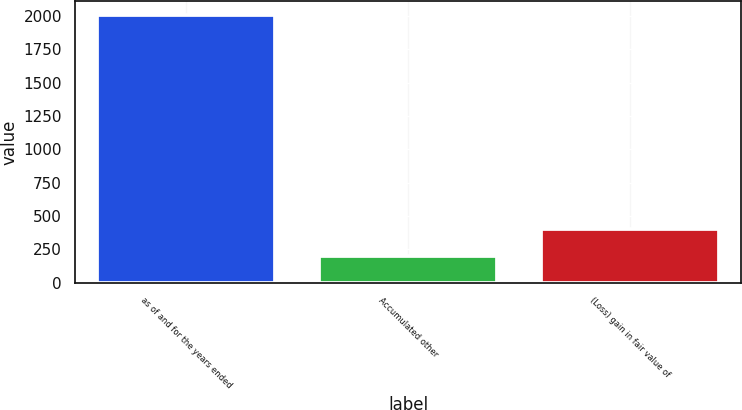<chart> <loc_0><loc_0><loc_500><loc_500><bar_chart><fcel>as of and for the years ended<fcel>Accumulated other<fcel>(Loss) gain in fair value of<nl><fcel>2012<fcel>203<fcel>404<nl></chart> 